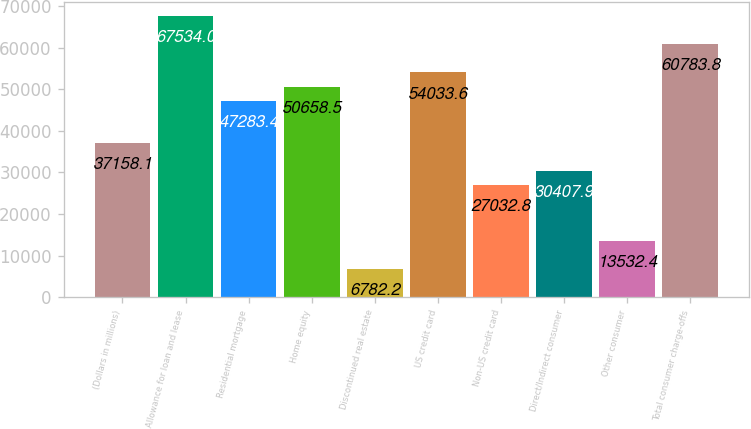<chart> <loc_0><loc_0><loc_500><loc_500><bar_chart><fcel>(Dollars in millions)<fcel>Allowance for loan and lease<fcel>Residential mortgage<fcel>Home equity<fcel>Discontinued real estate<fcel>US credit card<fcel>Non-US credit card<fcel>Direct/Indirect consumer<fcel>Other consumer<fcel>Total consumer charge-offs<nl><fcel>37158.1<fcel>67534<fcel>47283.4<fcel>50658.5<fcel>6782.2<fcel>54033.6<fcel>27032.8<fcel>30407.9<fcel>13532.4<fcel>60783.8<nl></chart> 